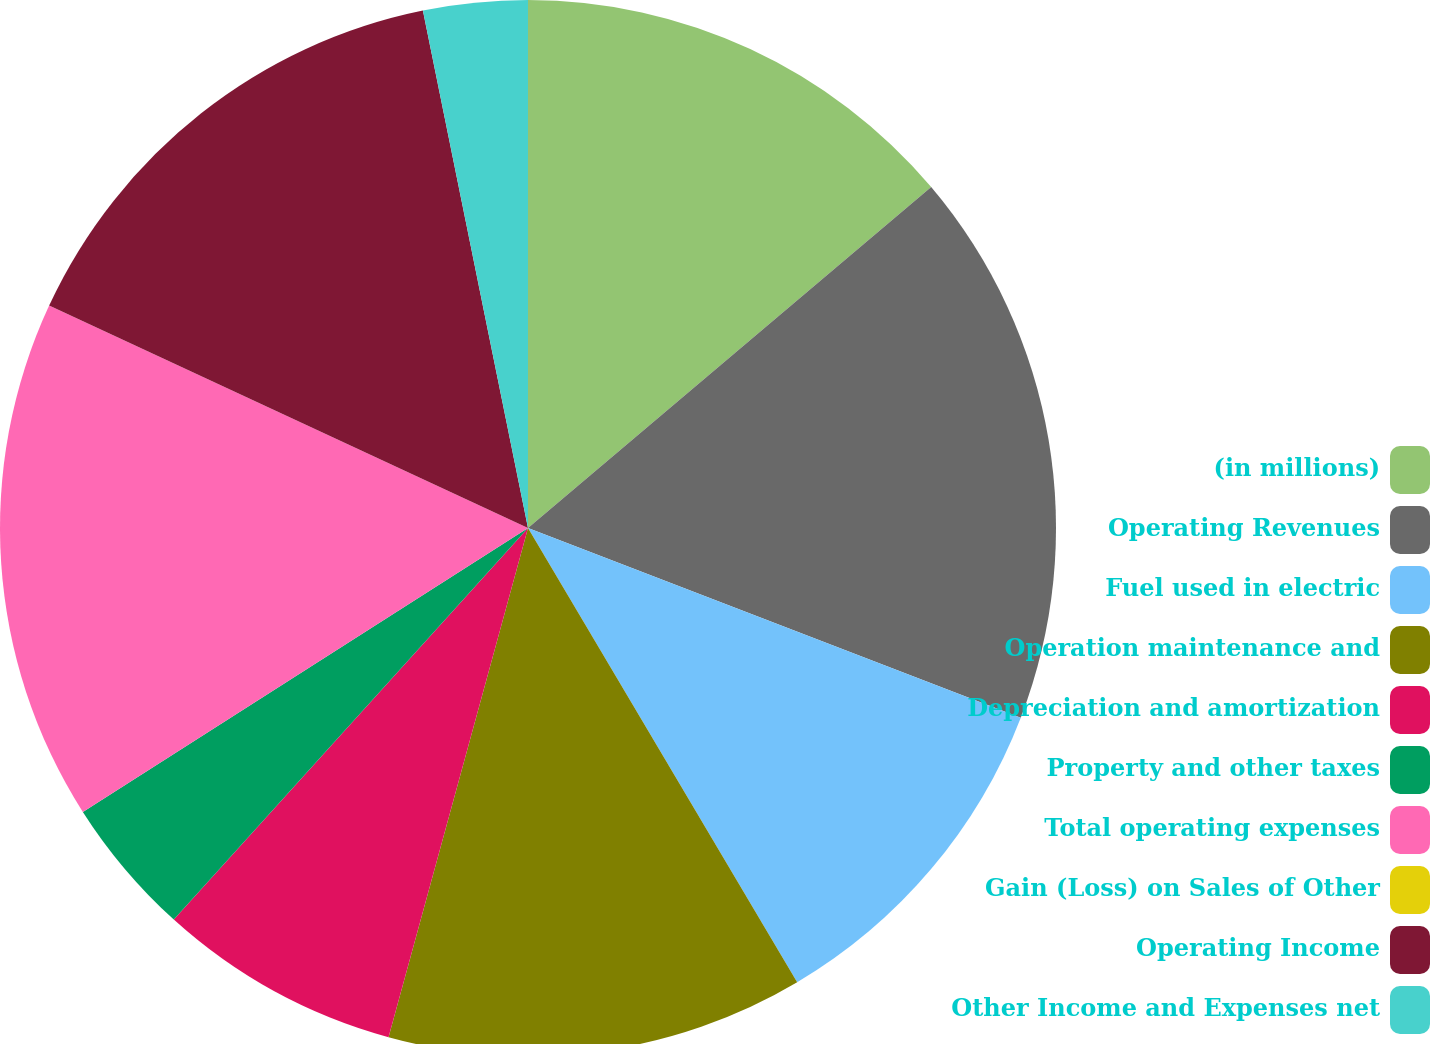Convert chart. <chart><loc_0><loc_0><loc_500><loc_500><pie_chart><fcel>(in millions)<fcel>Operating Revenues<fcel>Fuel used in electric<fcel>Operation maintenance and<fcel>Depreciation and amortization<fcel>Property and other taxes<fcel>Total operating expenses<fcel>Gain (Loss) on Sales of Other<fcel>Operating Income<fcel>Other Income and Expenses net<nl><fcel>13.83%<fcel>17.02%<fcel>10.64%<fcel>12.77%<fcel>7.45%<fcel>4.26%<fcel>15.96%<fcel>0.0%<fcel>14.89%<fcel>3.19%<nl></chart> 